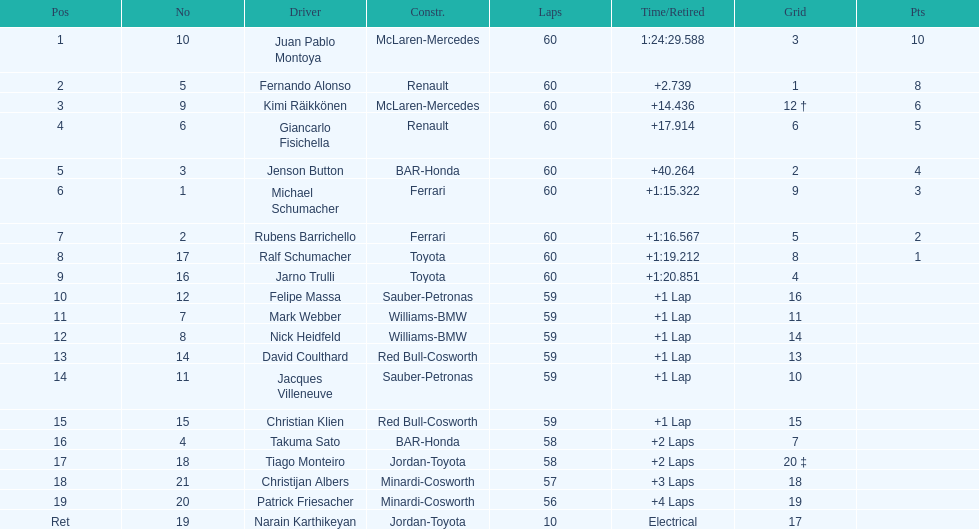After 8th position, how many points does a driver receive? 0. 